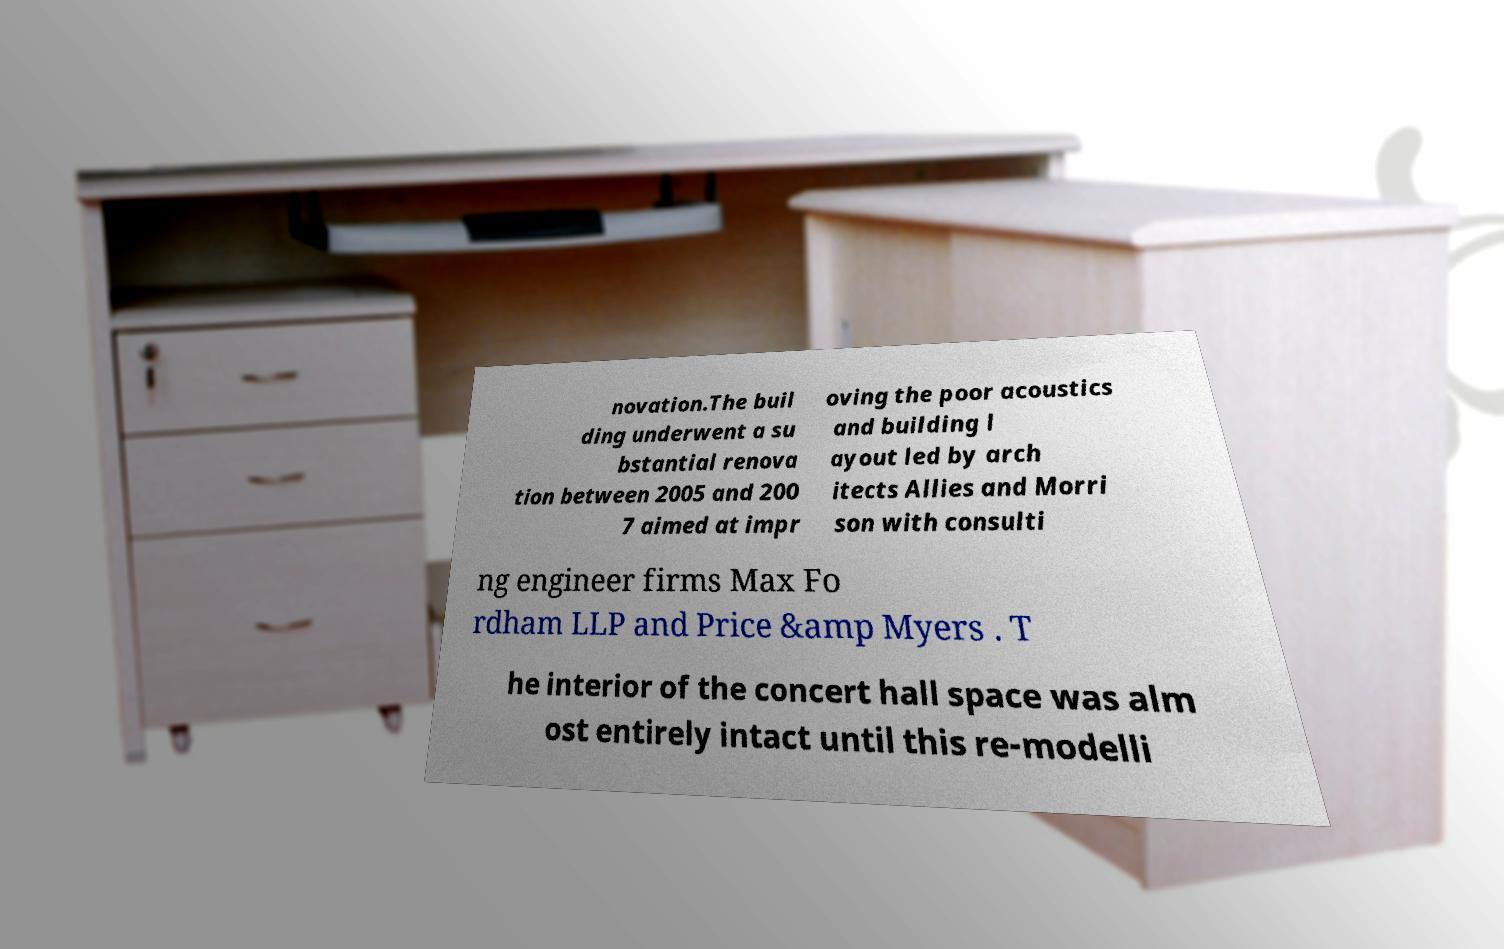Please read and relay the text visible in this image. What does it say? novation.The buil ding underwent a su bstantial renova tion between 2005 and 200 7 aimed at impr oving the poor acoustics and building l ayout led by arch itects Allies and Morri son with consulti ng engineer firms Max Fo rdham LLP and Price &amp Myers . T he interior of the concert hall space was alm ost entirely intact until this re-modelli 